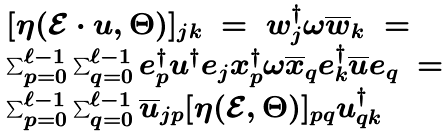Convert formula to latex. <formula><loc_0><loc_0><loc_500><loc_500>\begin{array} { l } [ \eta ( \mathcal { E } \cdot u , \Theta ) ] _ { j k } \ = \ w _ { j } ^ { \dagger } \omega \overline { w } _ { k } \ = \\ \sum _ { p = 0 } ^ { \ell - 1 } \sum _ { q = 0 } ^ { \ell - 1 } e _ { p } ^ { \dagger } u ^ { \dagger } e _ { j } x _ { p } ^ { \dagger } \omega \overline { x } _ { q } e _ { k } ^ { \dagger } \overline { u } e _ { q } \ = \ \\ \sum _ { p = 0 } ^ { \ell - 1 } \sum _ { q = 0 } ^ { \ell - 1 } \overline { u } _ { j p } [ \eta ( \mathcal { E } , \Theta ) ] _ { p q } u ^ { \dagger } _ { q k } \\ \end{array}</formula> 